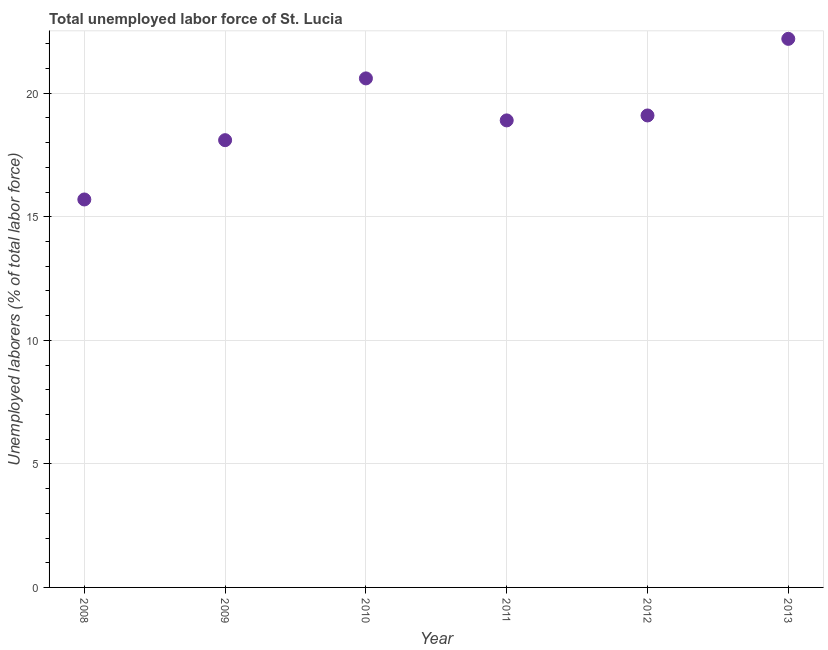What is the total unemployed labour force in 2012?
Your answer should be very brief. 19.1. Across all years, what is the maximum total unemployed labour force?
Keep it short and to the point. 22.2. Across all years, what is the minimum total unemployed labour force?
Make the answer very short. 15.7. In which year was the total unemployed labour force maximum?
Ensure brevity in your answer.  2013. In which year was the total unemployed labour force minimum?
Provide a short and direct response. 2008. What is the sum of the total unemployed labour force?
Ensure brevity in your answer.  114.6. What is the difference between the total unemployed labour force in 2011 and 2012?
Your answer should be very brief. -0.2. What is the average total unemployed labour force per year?
Your response must be concise. 19.1. What is the median total unemployed labour force?
Provide a succinct answer. 19. In how many years, is the total unemployed labour force greater than 13 %?
Provide a succinct answer. 6. Do a majority of the years between 2012 and 2008 (inclusive) have total unemployed labour force greater than 9 %?
Make the answer very short. Yes. What is the ratio of the total unemployed labour force in 2010 to that in 2012?
Your answer should be compact. 1.08. Is the total unemployed labour force in 2008 less than that in 2012?
Ensure brevity in your answer.  Yes. What is the difference between the highest and the second highest total unemployed labour force?
Give a very brief answer. 1.6. Is the sum of the total unemployed labour force in 2009 and 2012 greater than the maximum total unemployed labour force across all years?
Provide a succinct answer. Yes. What is the difference between the highest and the lowest total unemployed labour force?
Your answer should be very brief. 6.5. How many years are there in the graph?
Your answer should be compact. 6. What is the difference between two consecutive major ticks on the Y-axis?
Give a very brief answer. 5. Does the graph contain any zero values?
Offer a very short reply. No. Does the graph contain grids?
Make the answer very short. Yes. What is the title of the graph?
Provide a succinct answer. Total unemployed labor force of St. Lucia. What is the label or title of the Y-axis?
Provide a succinct answer. Unemployed laborers (% of total labor force). What is the Unemployed laborers (% of total labor force) in 2008?
Your answer should be compact. 15.7. What is the Unemployed laborers (% of total labor force) in 2009?
Offer a terse response. 18.1. What is the Unemployed laborers (% of total labor force) in 2010?
Your answer should be very brief. 20.6. What is the Unemployed laborers (% of total labor force) in 2011?
Provide a succinct answer. 18.9. What is the Unemployed laborers (% of total labor force) in 2012?
Give a very brief answer. 19.1. What is the Unemployed laborers (% of total labor force) in 2013?
Ensure brevity in your answer.  22.2. What is the difference between the Unemployed laborers (% of total labor force) in 2008 and 2012?
Make the answer very short. -3.4. What is the difference between the Unemployed laborers (% of total labor force) in 2008 and 2013?
Your answer should be compact. -6.5. What is the difference between the Unemployed laborers (% of total labor force) in 2009 and 2010?
Make the answer very short. -2.5. What is the difference between the Unemployed laborers (% of total labor force) in 2009 and 2011?
Offer a terse response. -0.8. What is the difference between the Unemployed laborers (% of total labor force) in 2009 and 2012?
Offer a very short reply. -1. What is the difference between the Unemployed laborers (% of total labor force) in 2011 and 2012?
Offer a very short reply. -0.2. What is the difference between the Unemployed laborers (% of total labor force) in 2011 and 2013?
Give a very brief answer. -3.3. What is the ratio of the Unemployed laborers (% of total labor force) in 2008 to that in 2009?
Ensure brevity in your answer.  0.87. What is the ratio of the Unemployed laborers (% of total labor force) in 2008 to that in 2010?
Provide a succinct answer. 0.76. What is the ratio of the Unemployed laborers (% of total labor force) in 2008 to that in 2011?
Offer a very short reply. 0.83. What is the ratio of the Unemployed laborers (% of total labor force) in 2008 to that in 2012?
Offer a terse response. 0.82. What is the ratio of the Unemployed laborers (% of total labor force) in 2008 to that in 2013?
Keep it short and to the point. 0.71. What is the ratio of the Unemployed laborers (% of total labor force) in 2009 to that in 2010?
Your response must be concise. 0.88. What is the ratio of the Unemployed laborers (% of total labor force) in 2009 to that in 2011?
Your answer should be compact. 0.96. What is the ratio of the Unemployed laborers (% of total labor force) in 2009 to that in 2012?
Your answer should be very brief. 0.95. What is the ratio of the Unemployed laborers (% of total labor force) in 2009 to that in 2013?
Your answer should be very brief. 0.81. What is the ratio of the Unemployed laborers (% of total labor force) in 2010 to that in 2011?
Provide a short and direct response. 1.09. What is the ratio of the Unemployed laborers (% of total labor force) in 2010 to that in 2012?
Provide a succinct answer. 1.08. What is the ratio of the Unemployed laborers (% of total labor force) in 2010 to that in 2013?
Offer a very short reply. 0.93. What is the ratio of the Unemployed laborers (% of total labor force) in 2011 to that in 2013?
Your response must be concise. 0.85. What is the ratio of the Unemployed laborers (% of total labor force) in 2012 to that in 2013?
Give a very brief answer. 0.86. 